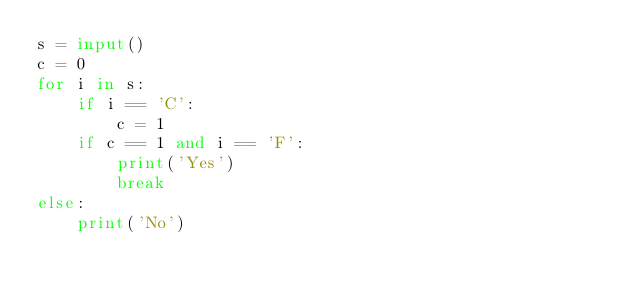<code> <loc_0><loc_0><loc_500><loc_500><_Python_>s = input()
c = 0
for i in s:
    if i == 'C':
        c = 1
    if c == 1 and i == 'F':
        print('Yes')
        break
else:
    print('No')</code> 